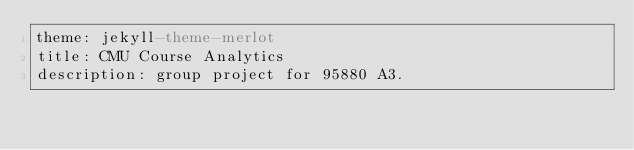<code> <loc_0><loc_0><loc_500><loc_500><_YAML_>theme: jekyll-theme-merlot
title: CMU Course Analytics
description: group project for 95880 A3.
</code> 